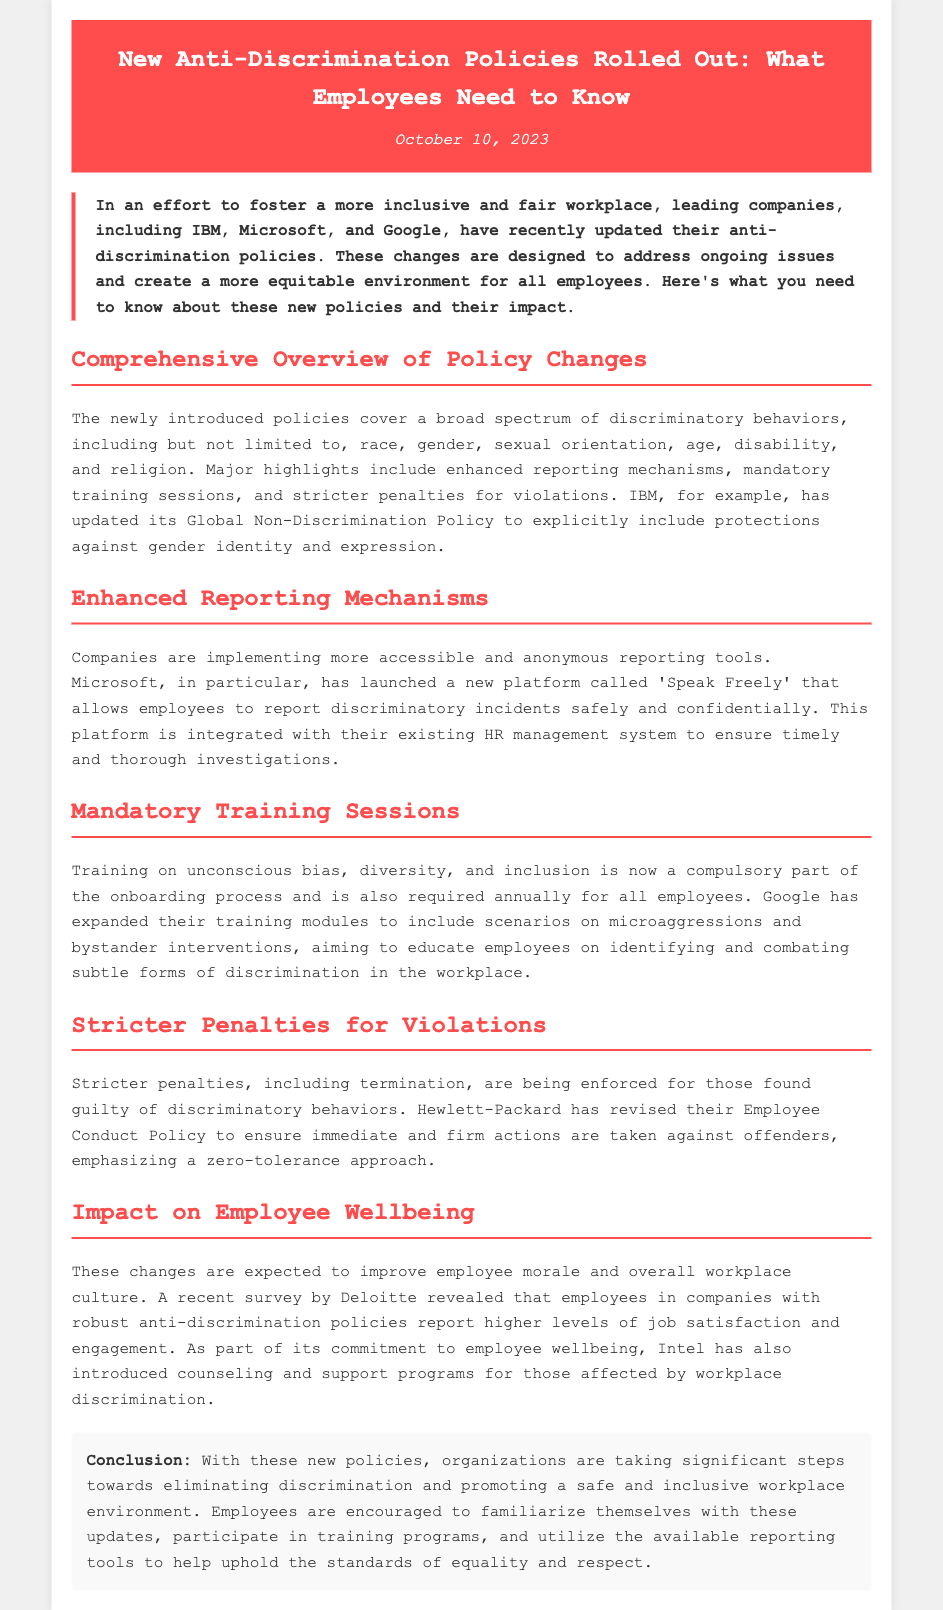What date was the press release issued? The document specifies the date of the press release in the header section, which is October 10, 2023.
Answer: October 10, 2023 Which three companies updated their anti-discrimination policies? The introduction mentions three leading companies that updated their policies: IBM, Microsoft, and Google.
Answer: IBM, Microsoft, Google What is the name of Microsoft's new reporting platform? The section on Enhanced Reporting Mechanisms specifies that Microsoft's new platform is called 'Speak Freely'.
Answer: Speak Freely What type of training is now mandatory for employees? The section on Mandatory Training Sessions states that training on unconscious bias, diversity, and inclusion is compulsory for all employees.
Answer: Unconscious bias, diversity, and inclusion What penalty may be enforced for discriminatory behaviors? The Stricter Penalties for Violations section mentions that termination may be imposed on those guilty of discriminatory behaviors.
Answer: Termination What impact do the new policies aim to have on employee morale? The section discusses the positive effects of the changes, specifically noting that these improvements are expected to enhance employee morale.
Answer: Improve morale Which company introduced counseling and support programs? The Impact on Employee Wellbeing section states that Intel has introduced counseling and support programs for those affected by workplace discrimination.
Answer: Intel 